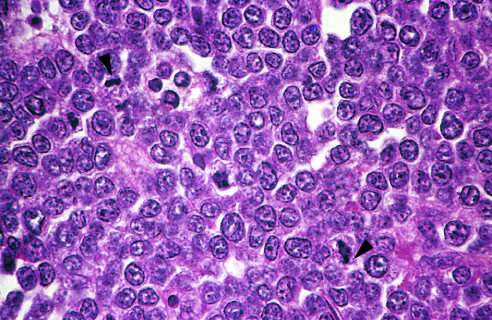what is better appreciated at a lower magnification?
Answer the question using a single word or phrase. Normal macrophages 